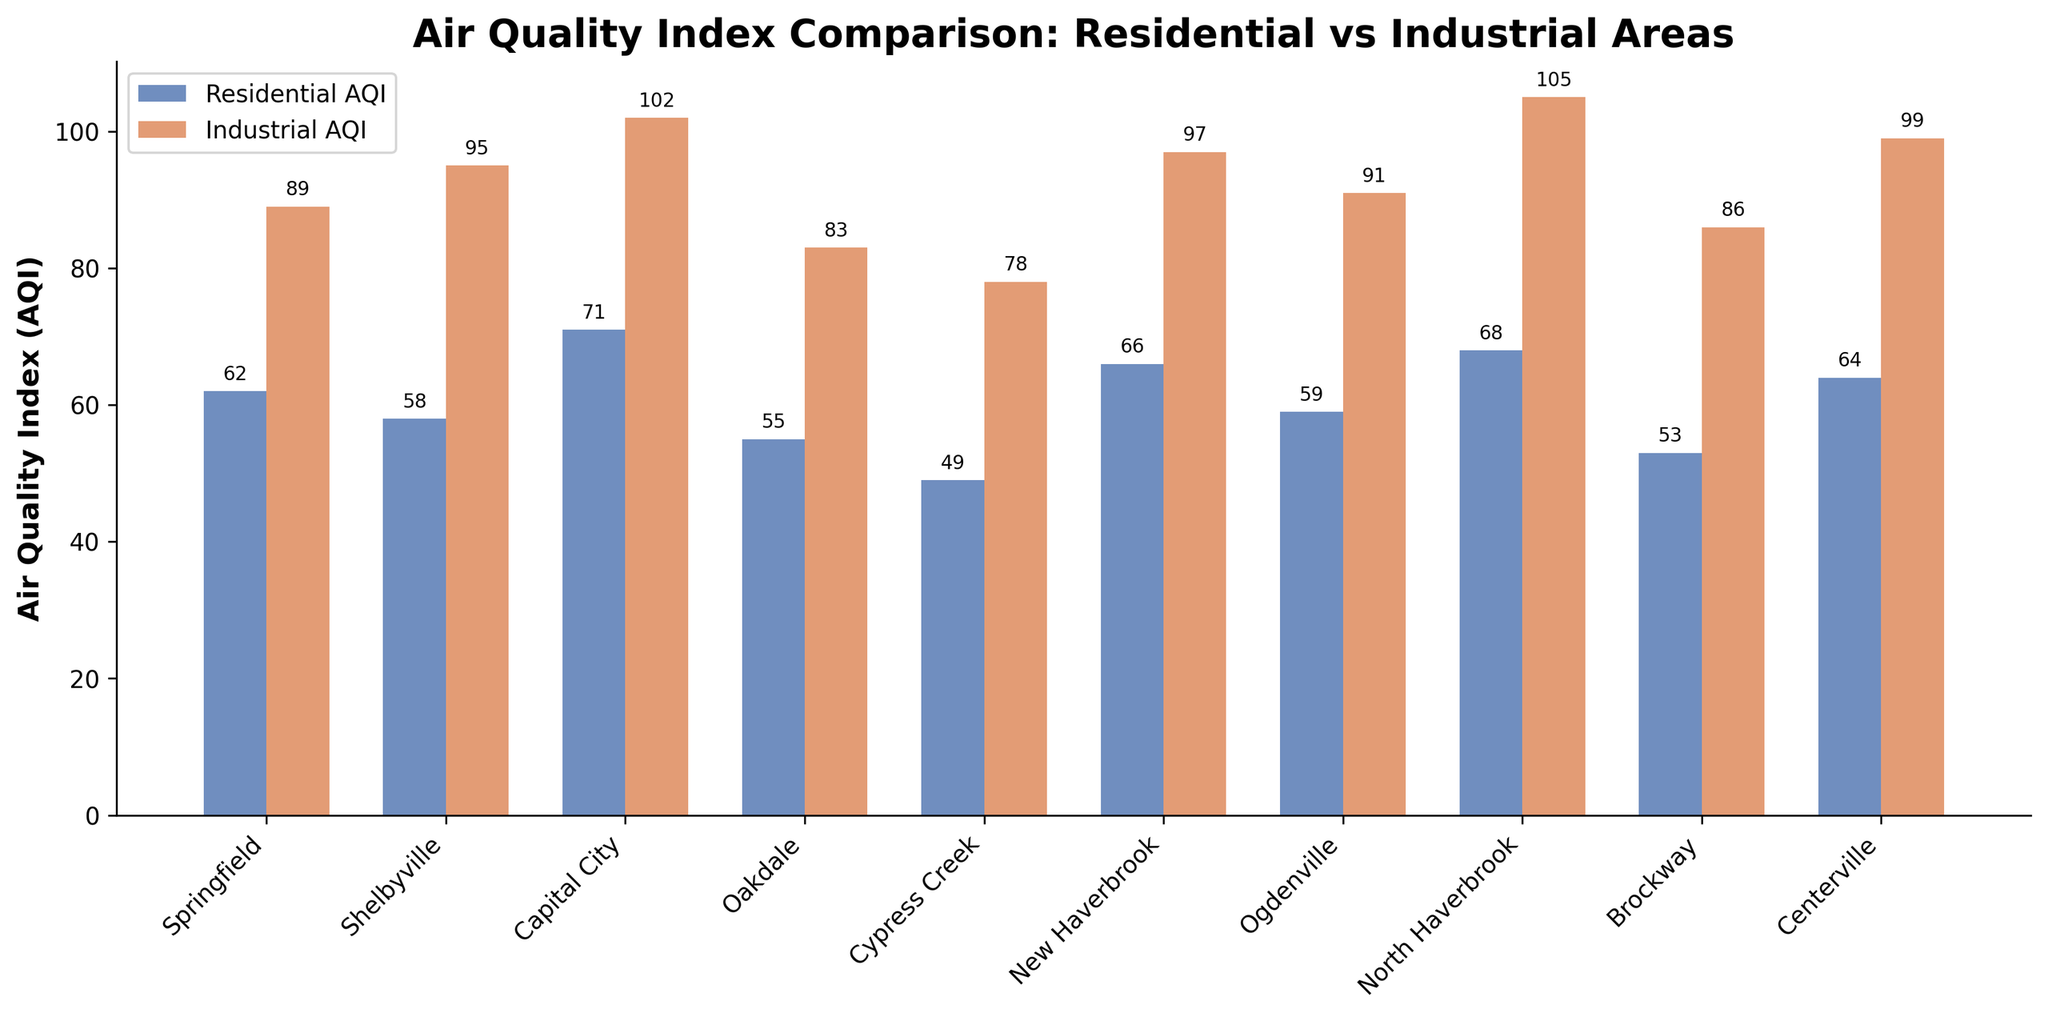Which location has the highest Industrial AQI? Look for the tallest bar in the Industrial AQI category. North Haverbrook has the tallest red bar, indicating the highest Industrial AQI.
Answer: North Haverbrook What is the difference between the highest Residential AQI and the lowest Residential AQI? Identify the tallest and shortest bars in the Residential AQI category. Capital City has the highest Residential AQI (71) and Cypress Creek has the lowest (49). The difference is 71 - 49.
Answer: 22 Which locations have a higher Industrial AQI than Residential AQI? Compare the heights of the blue and red bars for each location. All the locations have a higher Industrial AQI than Residential AQI as the red bars are taller in every case.
Answer: Springfield, Shelbyville, Capital City, Oakdale, Cypress Creek, New Haverbrook, Ogdenville, North Haverbrook, Brockway, Centerville Which location has the largest difference between Residential AQI and Industrial AQI? Calculate the difference between the Industrial and Residential AQI for each location. North Haverbrook has the largest difference (105 - 68 = 37).
Answer: North Haverbrook Which location has the smallest difference between Residential AQI and Industrial AQI? Calculate the difference between the Industrial and Residential AQI for each location. Cypress Creek has the smallest difference (78 - 49 = 29).
Answer: Cypress Creek What are the average Residential AQI and Industrial AQI across all locations? Sum all Residential AQI values and divide by the number of locations. Repeat for Industrial AQI. The average Residential AQI is (62 + 58 + 71 + 55 + 49 + 66 + 59 + 68 + 53 + 64) / 10 = 60.5. The average Industrial AQI is (89 + 95 + 102 + 83 + 78 + 97 + 91 + 105 + 86 + 99) / 10 = 92.5.
Answer: 60.5, 92.5 Which location has the second-highest Residential AQI? Identify the second tallest bar in the Residential AQI category. New Haverbrook has the second-highest Residential AQI of 66, following Capital City's 71.
Answer: New Haverbrook In which location is the difference between Residential and Industrial AQI closest to 15? Calculate the difference between Industrial and Residential AQI for each location and find the one closest to 15. Shelbyville has a difference of 95 - 58 = 37, not 15. Checking others, Ogdenville has a difference of 32 (91 - 59), closer but still not exact. Brockway has a difference of 33 (86 - 53), and so on. The closest in the given dataset is Ogdenville with a difference of 32.
Answer: Ogdenville 